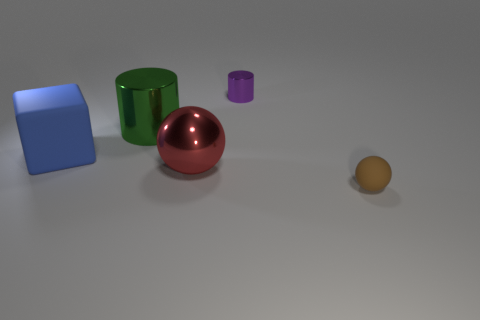How many large objects are cyan cylinders or red metal balls?
Keep it short and to the point. 1. The metal object that is the same size as the red metallic sphere is what color?
Your answer should be very brief. Green. How many other objects are there of the same shape as the brown rubber object?
Ensure brevity in your answer.  1. Are there any small purple objects that have the same material as the large red thing?
Make the answer very short. Yes. Does the cylinder that is behind the green metal object have the same material as the small thing in front of the large blue matte block?
Provide a succinct answer. No. What number of big purple metal cylinders are there?
Provide a short and direct response. 0. What shape is the small object that is behind the large blue rubber thing?
Your answer should be compact. Cylinder. How many other objects are there of the same size as the blue thing?
Make the answer very short. 2. Is the shape of the matte thing that is behind the tiny brown sphere the same as the large red metallic object to the left of the tiny metal cylinder?
Provide a succinct answer. No. What number of brown matte balls are right of the brown rubber ball?
Provide a short and direct response. 0. 